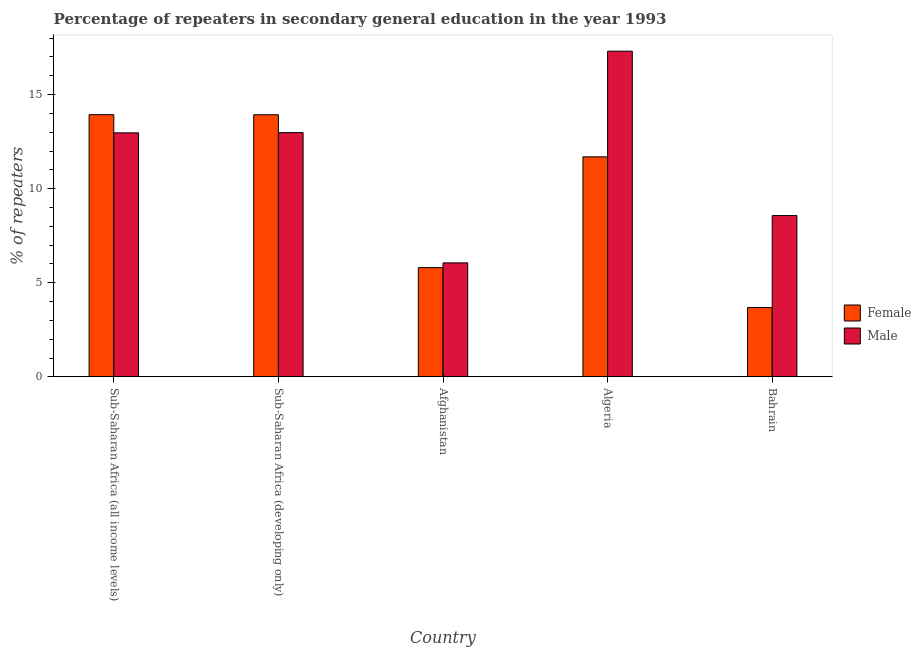How many different coloured bars are there?
Provide a short and direct response. 2. How many groups of bars are there?
Make the answer very short. 5. Are the number of bars per tick equal to the number of legend labels?
Your response must be concise. Yes. Are the number of bars on each tick of the X-axis equal?
Make the answer very short. Yes. How many bars are there on the 4th tick from the left?
Offer a very short reply. 2. How many bars are there on the 5th tick from the right?
Provide a short and direct response. 2. What is the label of the 5th group of bars from the left?
Keep it short and to the point. Bahrain. In how many cases, is the number of bars for a given country not equal to the number of legend labels?
Keep it short and to the point. 0. What is the percentage of male repeaters in Afghanistan?
Keep it short and to the point. 6.06. Across all countries, what is the maximum percentage of male repeaters?
Your answer should be compact. 17.31. Across all countries, what is the minimum percentage of male repeaters?
Keep it short and to the point. 6.06. In which country was the percentage of male repeaters maximum?
Give a very brief answer. Algeria. In which country was the percentage of male repeaters minimum?
Give a very brief answer. Afghanistan. What is the total percentage of female repeaters in the graph?
Your answer should be very brief. 49.05. What is the difference between the percentage of male repeaters in Afghanistan and that in Bahrain?
Your response must be concise. -2.51. What is the difference between the percentage of female repeaters in Sub-Saharan Africa (all income levels) and the percentage of male repeaters in Afghanistan?
Ensure brevity in your answer.  7.88. What is the average percentage of female repeaters per country?
Make the answer very short. 9.81. What is the difference between the percentage of female repeaters and percentage of male repeaters in Afghanistan?
Offer a very short reply. -0.25. What is the ratio of the percentage of female repeaters in Afghanistan to that in Algeria?
Provide a short and direct response. 0.5. Is the percentage of male repeaters in Sub-Saharan Africa (all income levels) less than that in Sub-Saharan Africa (developing only)?
Give a very brief answer. Yes. What is the difference between the highest and the second highest percentage of male repeaters?
Make the answer very short. 4.33. What is the difference between the highest and the lowest percentage of female repeaters?
Offer a very short reply. 10.25. In how many countries, is the percentage of female repeaters greater than the average percentage of female repeaters taken over all countries?
Provide a short and direct response. 3. Is the sum of the percentage of male repeaters in Algeria and Sub-Saharan Africa (developing only) greater than the maximum percentage of female repeaters across all countries?
Give a very brief answer. Yes. How many bars are there?
Keep it short and to the point. 10. Are all the bars in the graph horizontal?
Provide a short and direct response. No. Are the values on the major ticks of Y-axis written in scientific E-notation?
Give a very brief answer. No. What is the title of the graph?
Your answer should be compact. Percentage of repeaters in secondary general education in the year 1993. Does "Goods" appear as one of the legend labels in the graph?
Provide a succinct answer. No. What is the label or title of the X-axis?
Your answer should be compact. Country. What is the label or title of the Y-axis?
Make the answer very short. % of repeaters. What is the % of repeaters of Female in Sub-Saharan Africa (all income levels)?
Make the answer very short. 13.93. What is the % of repeaters in Male in Sub-Saharan Africa (all income levels)?
Make the answer very short. 12.97. What is the % of repeaters in Female in Sub-Saharan Africa (developing only)?
Give a very brief answer. 13.93. What is the % of repeaters in Male in Sub-Saharan Africa (developing only)?
Keep it short and to the point. 12.98. What is the % of repeaters of Female in Afghanistan?
Your response must be concise. 5.81. What is the % of repeaters of Male in Afghanistan?
Ensure brevity in your answer.  6.06. What is the % of repeaters in Female in Algeria?
Your answer should be compact. 11.69. What is the % of repeaters of Male in Algeria?
Give a very brief answer. 17.31. What is the % of repeaters in Female in Bahrain?
Provide a short and direct response. 3.68. What is the % of repeaters in Male in Bahrain?
Your response must be concise. 8.57. Across all countries, what is the maximum % of repeaters in Female?
Offer a terse response. 13.93. Across all countries, what is the maximum % of repeaters in Male?
Your answer should be very brief. 17.31. Across all countries, what is the minimum % of repeaters in Female?
Ensure brevity in your answer.  3.68. Across all countries, what is the minimum % of repeaters in Male?
Ensure brevity in your answer.  6.06. What is the total % of repeaters in Female in the graph?
Offer a very short reply. 49.05. What is the total % of repeaters in Male in the graph?
Make the answer very short. 57.89. What is the difference between the % of repeaters in Female in Sub-Saharan Africa (all income levels) and that in Sub-Saharan Africa (developing only)?
Make the answer very short. 0. What is the difference between the % of repeaters in Male in Sub-Saharan Africa (all income levels) and that in Sub-Saharan Africa (developing only)?
Your response must be concise. -0.01. What is the difference between the % of repeaters of Female in Sub-Saharan Africa (all income levels) and that in Afghanistan?
Offer a terse response. 8.13. What is the difference between the % of repeaters in Male in Sub-Saharan Africa (all income levels) and that in Afghanistan?
Provide a short and direct response. 6.91. What is the difference between the % of repeaters of Female in Sub-Saharan Africa (all income levels) and that in Algeria?
Offer a very short reply. 2.24. What is the difference between the % of repeaters in Male in Sub-Saharan Africa (all income levels) and that in Algeria?
Make the answer very short. -4.34. What is the difference between the % of repeaters of Female in Sub-Saharan Africa (all income levels) and that in Bahrain?
Provide a succinct answer. 10.25. What is the difference between the % of repeaters in Male in Sub-Saharan Africa (all income levels) and that in Bahrain?
Keep it short and to the point. 4.4. What is the difference between the % of repeaters in Female in Sub-Saharan Africa (developing only) and that in Afghanistan?
Provide a succinct answer. 8.12. What is the difference between the % of repeaters in Male in Sub-Saharan Africa (developing only) and that in Afghanistan?
Provide a succinct answer. 6.92. What is the difference between the % of repeaters in Female in Sub-Saharan Africa (developing only) and that in Algeria?
Provide a short and direct response. 2.24. What is the difference between the % of repeaters in Male in Sub-Saharan Africa (developing only) and that in Algeria?
Offer a terse response. -4.33. What is the difference between the % of repeaters in Female in Sub-Saharan Africa (developing only) and that in Bahrain?
Offer a very short reply. 10.25. What is the difference between the % of repeaters of Male in Sub-Saharan Africa (developing only) and that in Bahrain?
Your response must be concise. 4.41. What is the difference between the % of repeaters of Female in Afghanistan and that in Algeria?
Offer a very short reply. -5.89. What is the difference between the % of repeaters of Male in Afghanistan and that in Algeria?
Provide a succinct answer. -11.25. What is the difference between the % of repeaters of Female in Afghanistan and that in Bahrain?
Your answer should be very brief. 2.12. What is the difference between the % of repeaters of Male in Afghanistan and that in Bahrain?
Provide a succinct answer. -2.51. What is the difference between the % of repeaters of Female in Algeria and that in Bahrain?
Offer a terse response. 8.01. What is the difference between the % of repeaters of Male in Algeria and that in Bahrain?
Make the answer very short. 8.74. What is the difference between the % of repeaters of Female in Sub-Saharan Africa (all income levels) and the % of repeaters of Male in Sub-Saharan Africa (developing only)?
Ensure brevity in your answer.  0.95. What is the difference between the % of repeaters of Female in Sub-Saharan Africa (all income levels) and the % of repeaters of Male in Afghanistan?
Your answer should be compact. 7.88. What is the difference between the % of repeaters of Female in Sub-Saharan Africa (all income levels) and the % of repeaters of Male in Algeria?
Your answer should be very brief. -3.38. What is the difference between the % of repeaters in Female in Sub-Saharan Africa (all income levels) and the % of repeaters in Male in Bahrain?
Offer a terse response. 5.36. What is the difference between the % of repeaters of Female in Sub-Saharan Africa (developing only) and the % of repeaters of Male in Afghanistan?
Ensure brevity in your answer.  7.87. What is the difference between the % of repeaters in Female in Sub-Saharan Africa (developing only) and the % of repeaters in Male in Algeria?
Offer a very short reply. -3.38. What is the difference between the % of repeaters of Female in Sub-Saharan Africa (developing only) and the % of repeaters of Male in Bahrain?
Keep it short and to the point. 5.36. What is the difference between the % of repeaters in Female in Afghanistan and the % of repeaters in Male in Algeria?
Keep it short and to the point. -11.5. What is the difference between the % of repeaters in Female in Afghanistan and the % of repeaters in Male in Bahrain?
Offer a very short reply. -2.76. What is the difference between the % of repeaters of Female in Algeria and the % of repeaters of Male in Bahrain?
Provide a short and direct response. 3.12. What is the average % of repeaters in Female per country?
Offer a very short reply. 9.81. What is the average % of repeaters in Male per country?
Provide a succinct answer. 11.58. What is the difference between the % of repeaters in Female and % of repeaters in Male in Sub-Saharan Africa (all income levels)?
Provide a succinct answer. 0.96. What is the difference between the % of repeaters in Female and % of repeaters in Male in Sub-Saharan Africa (developing only)?
Provide a succinct answer. 0.95. What is the difference between the % of repeaters of Female and % of repeaters of Male in Afghanistan?
Provide a succinct answer. -0.25. What is the difference between the % of repeaters of Female and % of repeaters of Male in Algeria?
Keep it short and to the point. -5.62. What is the difference between the % of repeaters of Female and % of repeaters of Male in Bahrain?
Your response must be concise. -4.89. What is the ratio of the % of repeaters of Female in Sub-Saharan Africa (all income levels) to that in Afghanistan?
Give a very brief answer. 2.4. What is the ratio of the % of repeaters of Male in Sub-Saharan Africa (all income levels) to that in Afghanistan?
Provide a succinct answer. 2.14. What is the ratio of the % of repeaters in Female in Sub-Saharan Africa (all income levels) to that in Algeria?
Your answer should be very brief. 1.19. What is the ratio of the % of repeaters of Male in Sub-Saharan Africa (all income levels) to that in Algeria?
Give a very brief answer. 0.75. What is the ratio of the % of repeaters in Female in Sub-Saharan Africa (all income levels) to that in Bahrain?
Ensure brevity in your answer.  3.78. What is the ratio of the % of repeaters in Male in Sub-Saharan Africa (all income levels) to that in Bahrain?
Keep it short and to the point. 1.51. What is the ratio of the % of repeaters of Female in Sub-Saharan Africa (developing only) to that in Afghanistan?
Make the answer very short. 2.4. What is the ratio of the % of repeaters of Male in Sub-Saharan Africa (developing only) to that in Afghanistan?
Provide a short and direct response. 2.14. What is the ratio of the % of repeaters of Female in Sub-Saharan Africa (developing only) to that in Algeria?
Ensure brevity in your answer.  1.19. What is the ratio of the % of repeaters in Male in Sub-Saharan Africa (developing only) to that in Algeria?
Your response must be concise. 0.75. What is the ratio of the % of repeaters in Female in Sub-Saharan Africa (developing only) to that in Bahrain?
Offer a terse response. 3.78. What is the ratio of the % of repeaters in Male in Sub-Saharan Africa (developing only) to that in Bahrain?
Your answer should be very brief. 1.51. What is the ratio of the % of repeaters in Female in Afghanistan to that in Algeria?
Ensure brevity in your answer.  0.5. What is the ratio of the % of repeaters of Male in Afghanistan to that in Algeria?
Your answer should be compact. 0.35. What is the ratio of the % of repeaters in Female in Afghanistan to that in Bahrain?
Your answer should be very brief. 1.58. What is the ratio of the % of repeaters in Male in Afghanistan to that in Bahrain?
Make the answer very short. 0.71. What is the ratio of the % of repeaters in Female in Algeria to that in Bahrain?
Offer a terse response. 3.17. What is the ratio of the % of repeaters of Male in Algeria to that in Bahrain?
Keep it short and to the point. 2.02. What is the difference between the highest and the second highest % of repeaters of Female?
Your answer should be compact. 0. What is the difference between the highest and the second highest % of repeaters in Male?
Your answer should be compact. 4.33. What is the difference between the highest and the lowest % of repeaters in Female?
Make the answer very short. 10.25. What is the difference between the highest and the lowest % of repeaters of Male?
Ensure brevity in your answer.  11.25. 